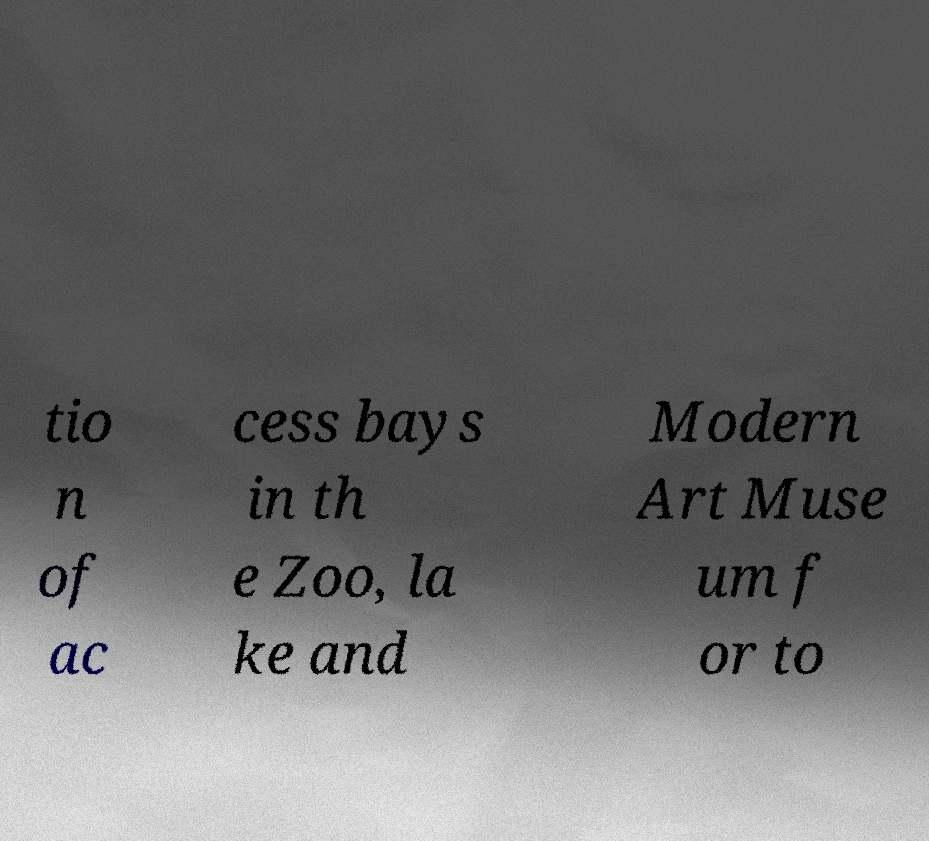I need the written content from this picture converted into text. Can you do that? tio n of ac cess bays in th e Zoo, la ke and Modern Art Muse um f or to 